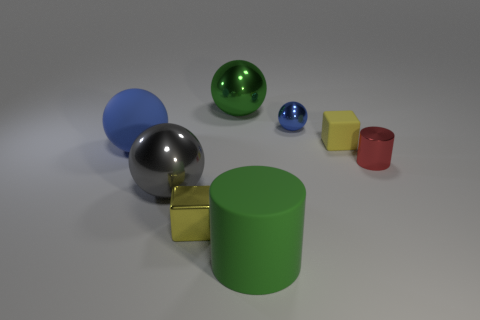Subtract all green balls. How many balls are left? 3 Subtract all tiny metallic balls. How many balls are left? 3 Add 2 tiny cubes. How many objects exist? 10 Subtract all purple spheres. Subtract all red blocks. How many spheres are left? 4 Subtract all cylinders. How many objects are left? 6 Add 2 big green metallic balls. How many big green metallic balls exist? 3 Subtract 0 brown cylinders. How many objects are left? 8 Subtract all cubes. Subtract all large green cylinders. How many objects are left? 5 Add 6 tiny metal balls. How many tiny metal balls are left? 7 